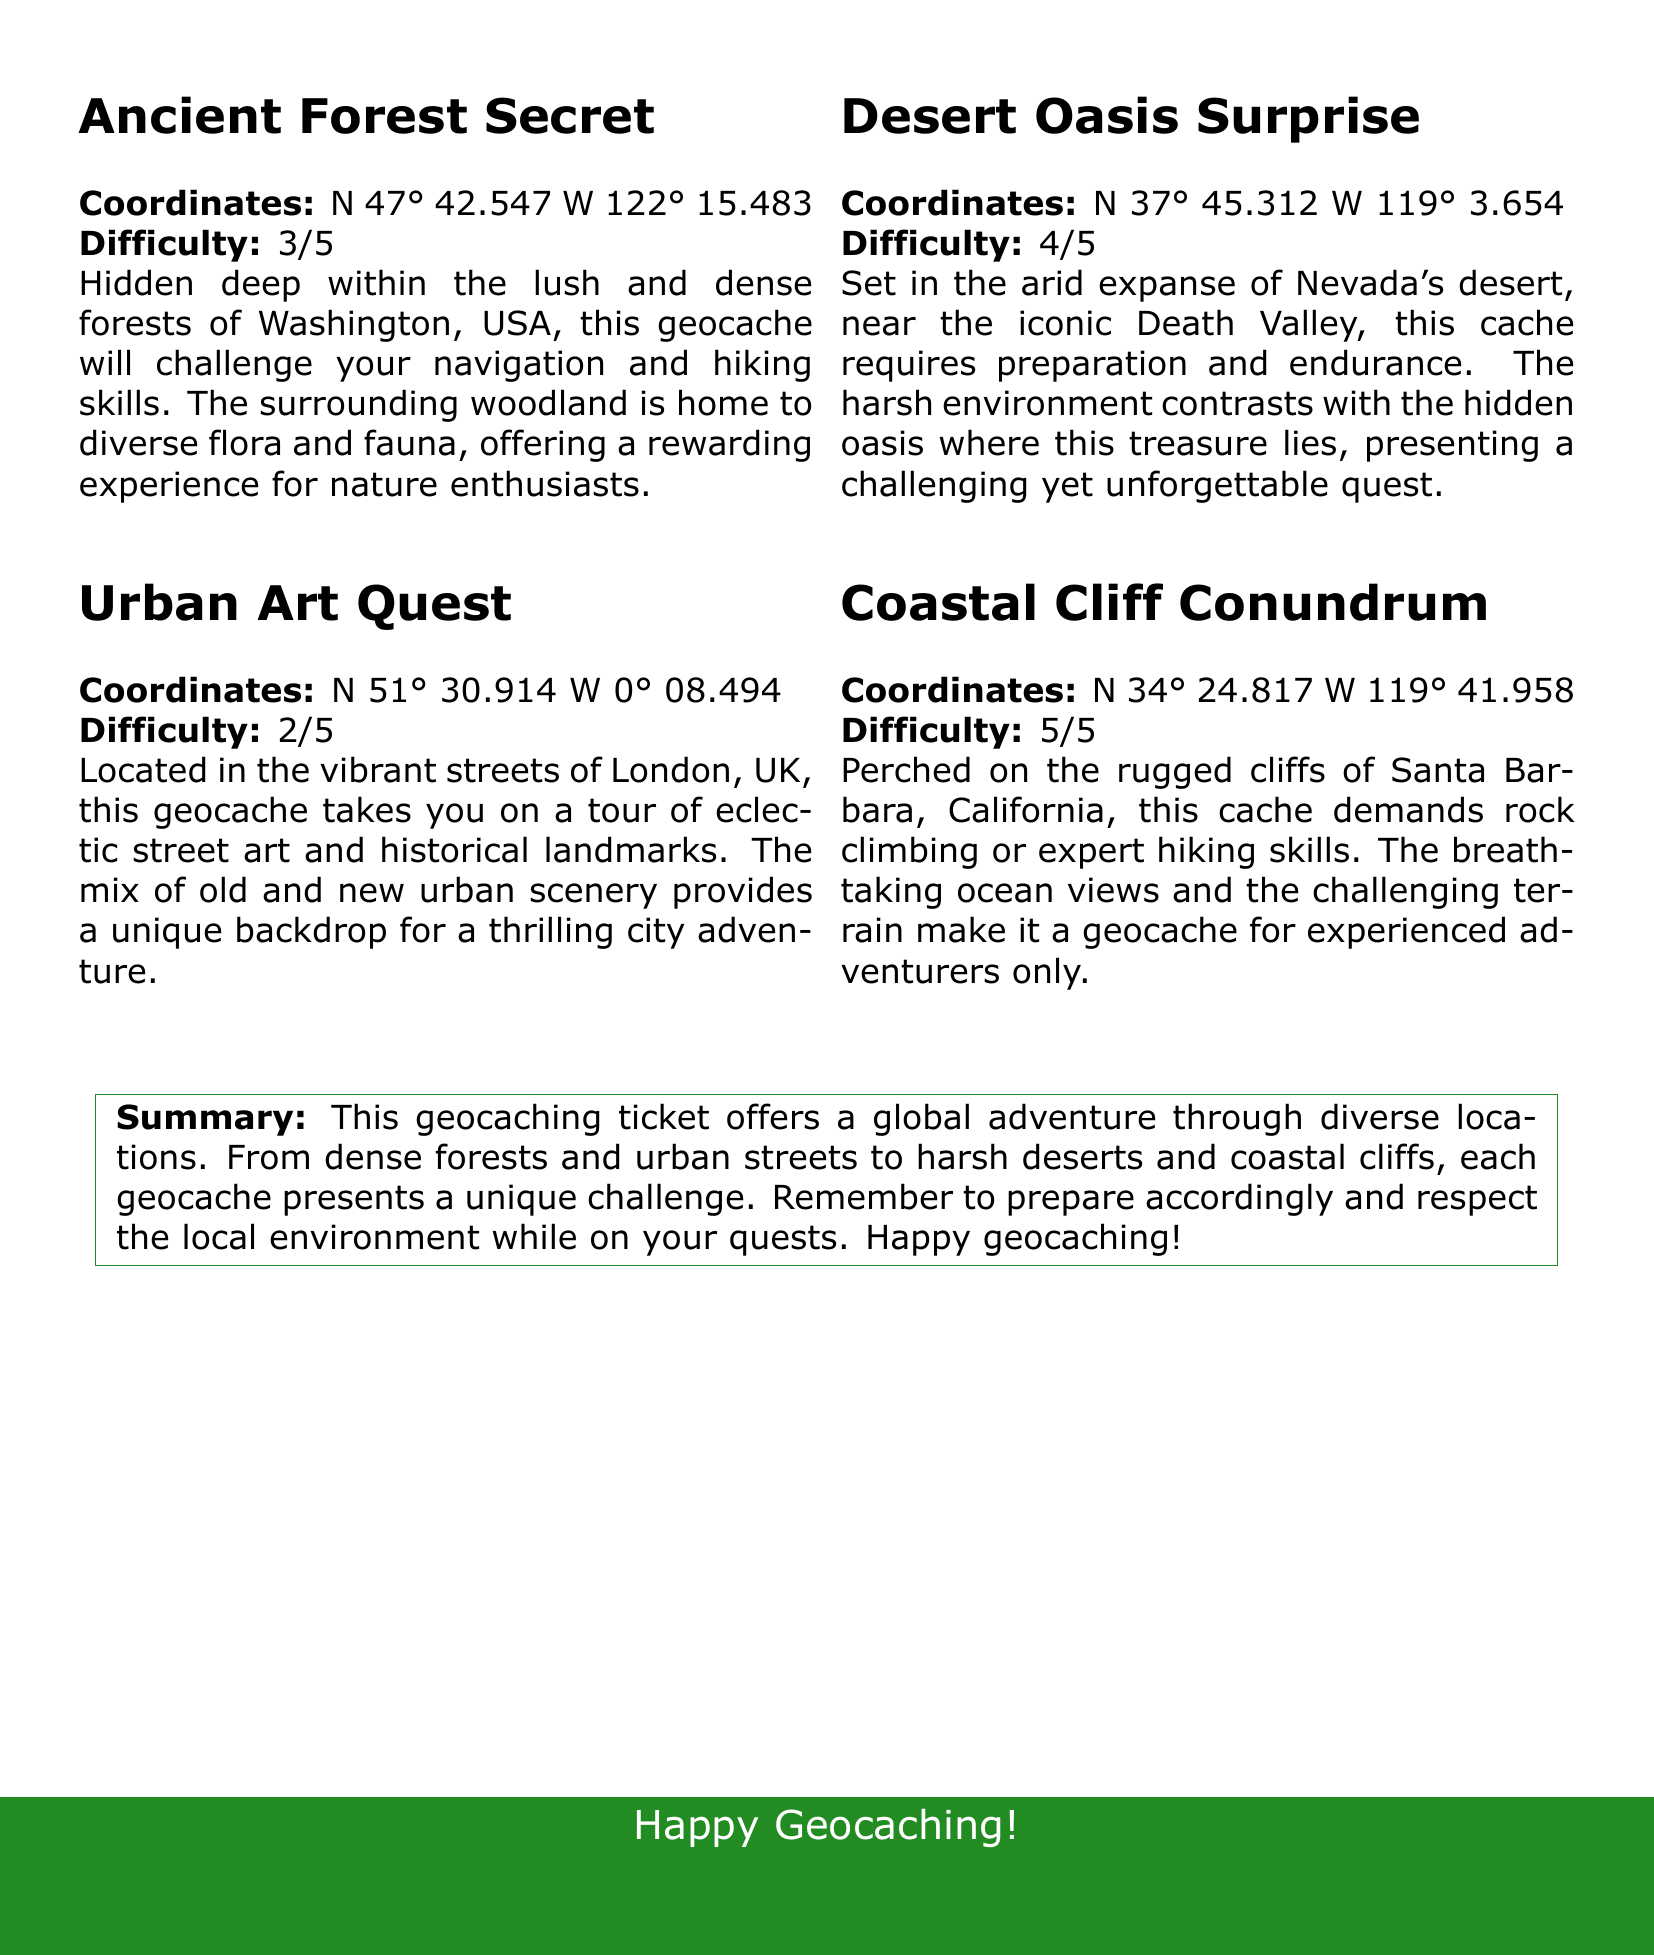What is the difficulty level of the Ancient Forest Secret? The difficulty level is specified in the document as 3 out of 5 for the Ancient Forest Secret.
Answer: 3/5 What are the coordinates for the Urban Art Quest? The document lists the coordinates for Urban Art Quest as N 51° 30.914 W 0° 08.494.
Answer: N 51° 30.914 W 0° 08.494 Which cache has the highest difficulty level? By comparing the difficulty levels provided, the Coastal Cliff Conundrum has the highest difficulty at 5 out of 5.
Answer: 5/5 Where is the Desert Oasis Surprise located? The document specifies that Desert Oasis Surprise is near Death Valley in Nevada.
Answer: Nevada What type of scenery does the Urban Art Quest showcase? The description highlights that Urban Art Quest showcases eclectic street art and historical landmarks in London.
Answer: Eclectic street art and historical landmarks How many geocaches are mentioned in the document? The document mentions a total of four geocaches in the summary.
Answer: Four What is the main recommendation when geocaching according to the summary? The summary recommends preparing accordingly and respecting the local environment while geocaching.
Answer: Prepare accordingly and respect the local environment What region is highlighted in the Ancient Forest Secret? The Ancient Forest Secret is located in the lush and dense forests of Washington, USA.
Answer: Washington, USA 